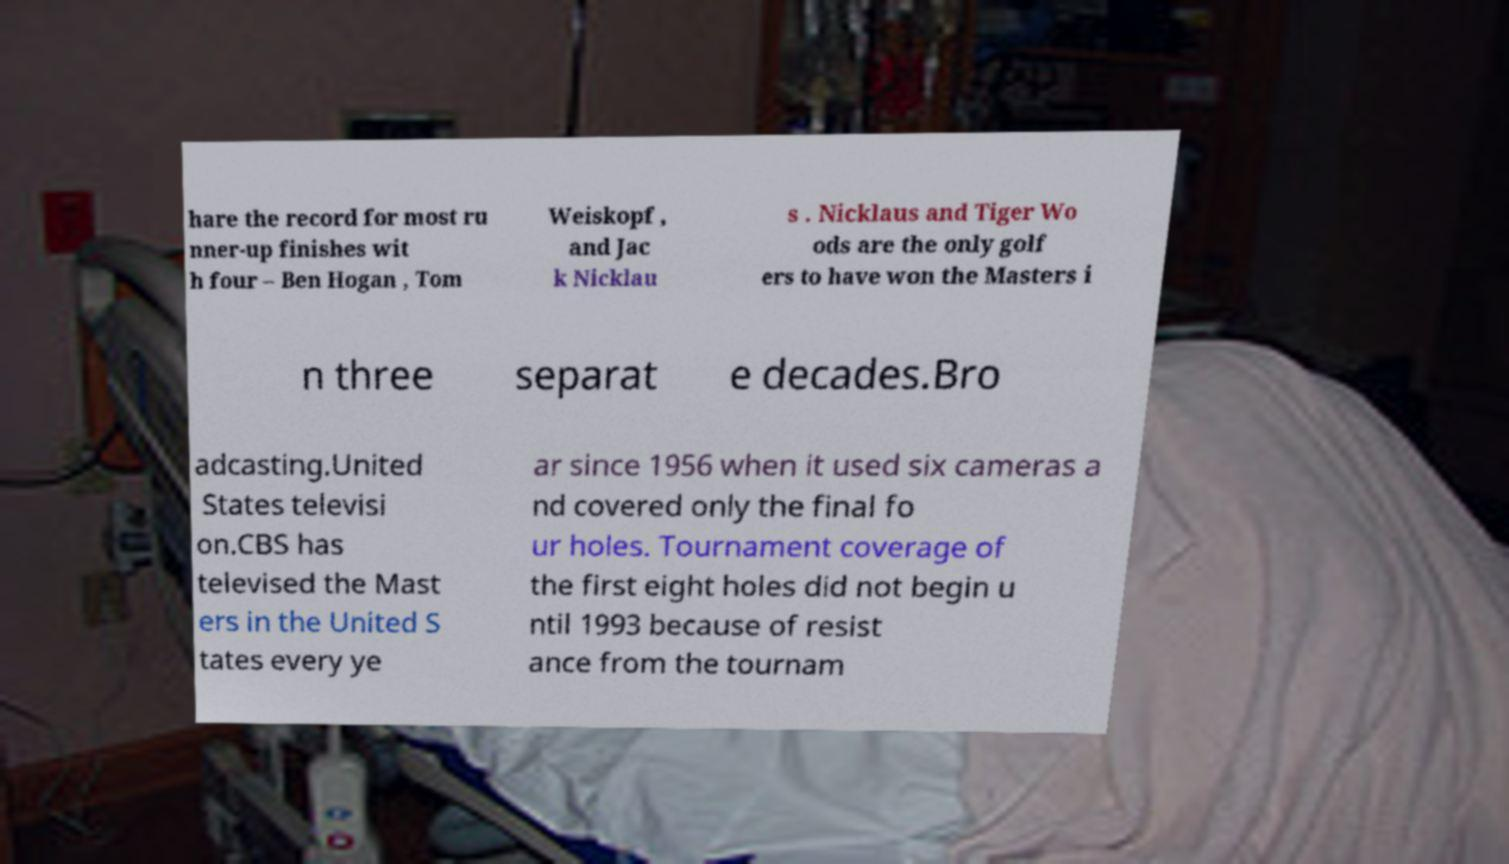Can you read and provide the text displayed in the image?This photo seems to have some interesting text. Can you extract and type it out for me? hare the record for most ru nner-up finishes wit h four – Ben Hogan , Tom Weiskopf , and Jac k Nicklau s . Nicklaus and Tiger Wo ods are the only golf ers to have won the Masters i n three separat e decades.Bro adcasting.United States televisi on.CBS has televised the Mast ers in the United S tates every ye ar since 1956 when it used six cameras a nd covered only the final fo ur holes. Tournament coverage of the first eight holes did not begin u ntil 1993 because of resist ance from the tournam 